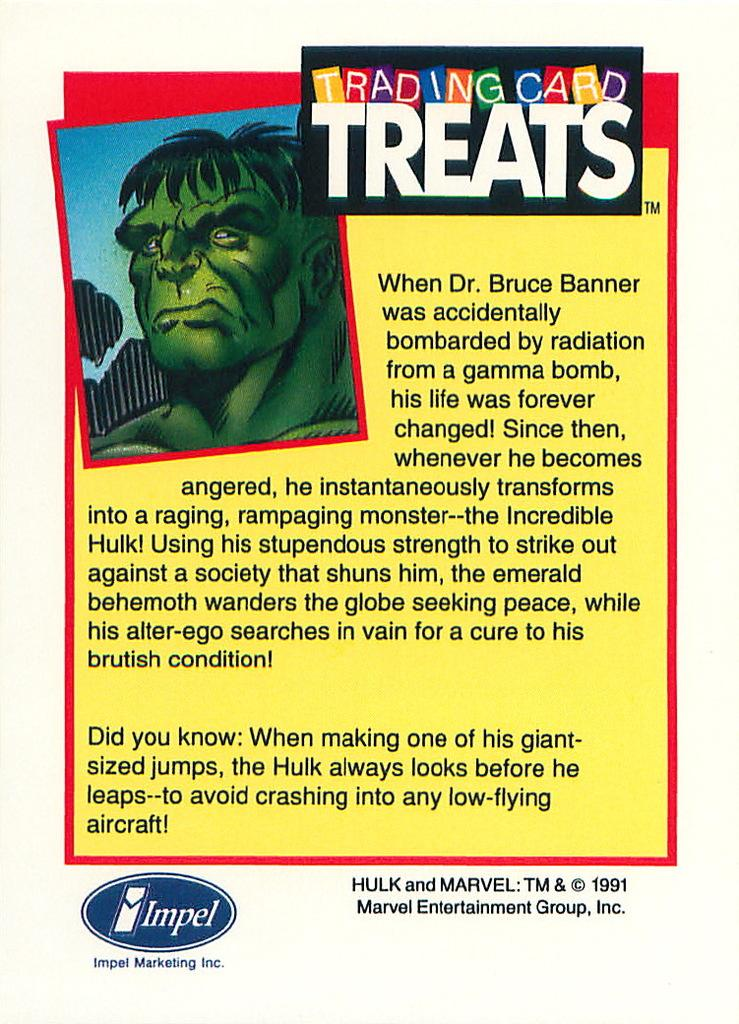What is present on the poster in the image? There is a poster in the image, and it contains an animated image. What type of content is on the poster? The poster contains an animated image and some information. What type of match can be seen on the poster? There is no match present on the poster; it contains an animated image and information. 